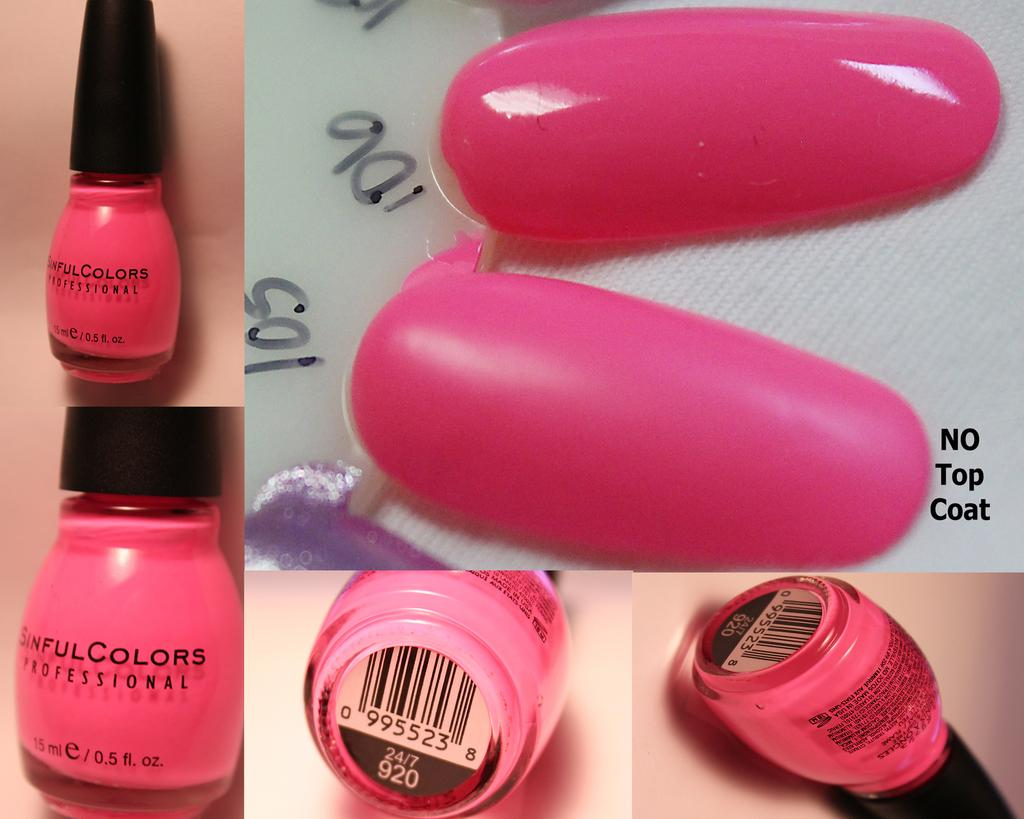Provide a one-sentence caption for the provided image. A pink color Sinful Colors Professional bottle of nailpolish shown from different angles. 